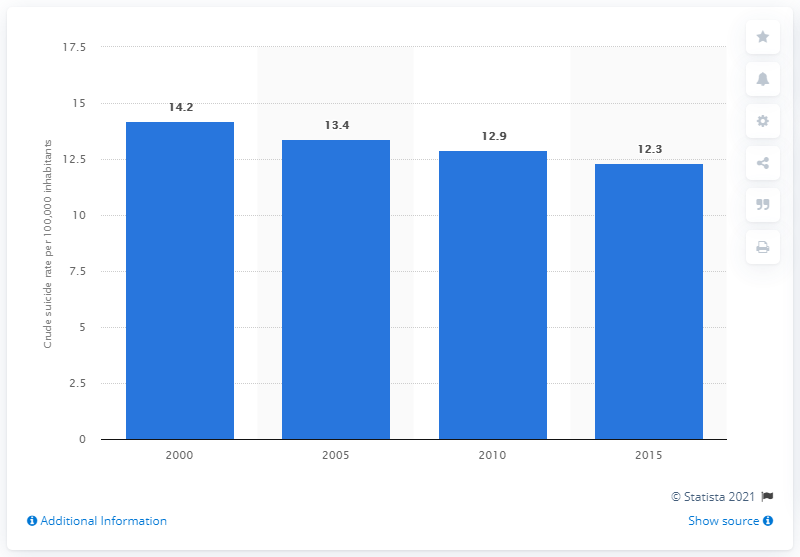Mention a couple of crucial points in this snapshot. In 2015, the crude suicide rate in Laos was 12.3 per 100,000 population. 